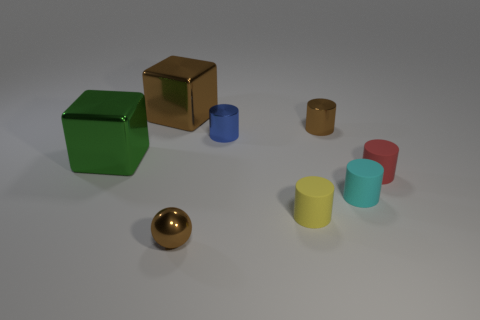Subtract all small rubber cylinders. How many cylinders are left? 2 Subtract all green cubes. How many cubes are left? 1 Subtract all cubes. How many objects are left? 6 Subtract 4 cylinders. How many cylinders are left? 1 Subtract all brown balls. How many red cylinders are left? 1 Add 1 small shiny cylinders. How many objects exist? 9 Add 3 big cyan rubber cubes. How many big cyan rubber cubes exist? 3 Subtract 1 blue cylinders. How many objects are left? 7 Subtract all cyan cylinders. Subtract all brown balls. How many cylinders are left? 4 Subtract all big green things. Subtract all tiny blue cylinders. How many objects are left? 6 